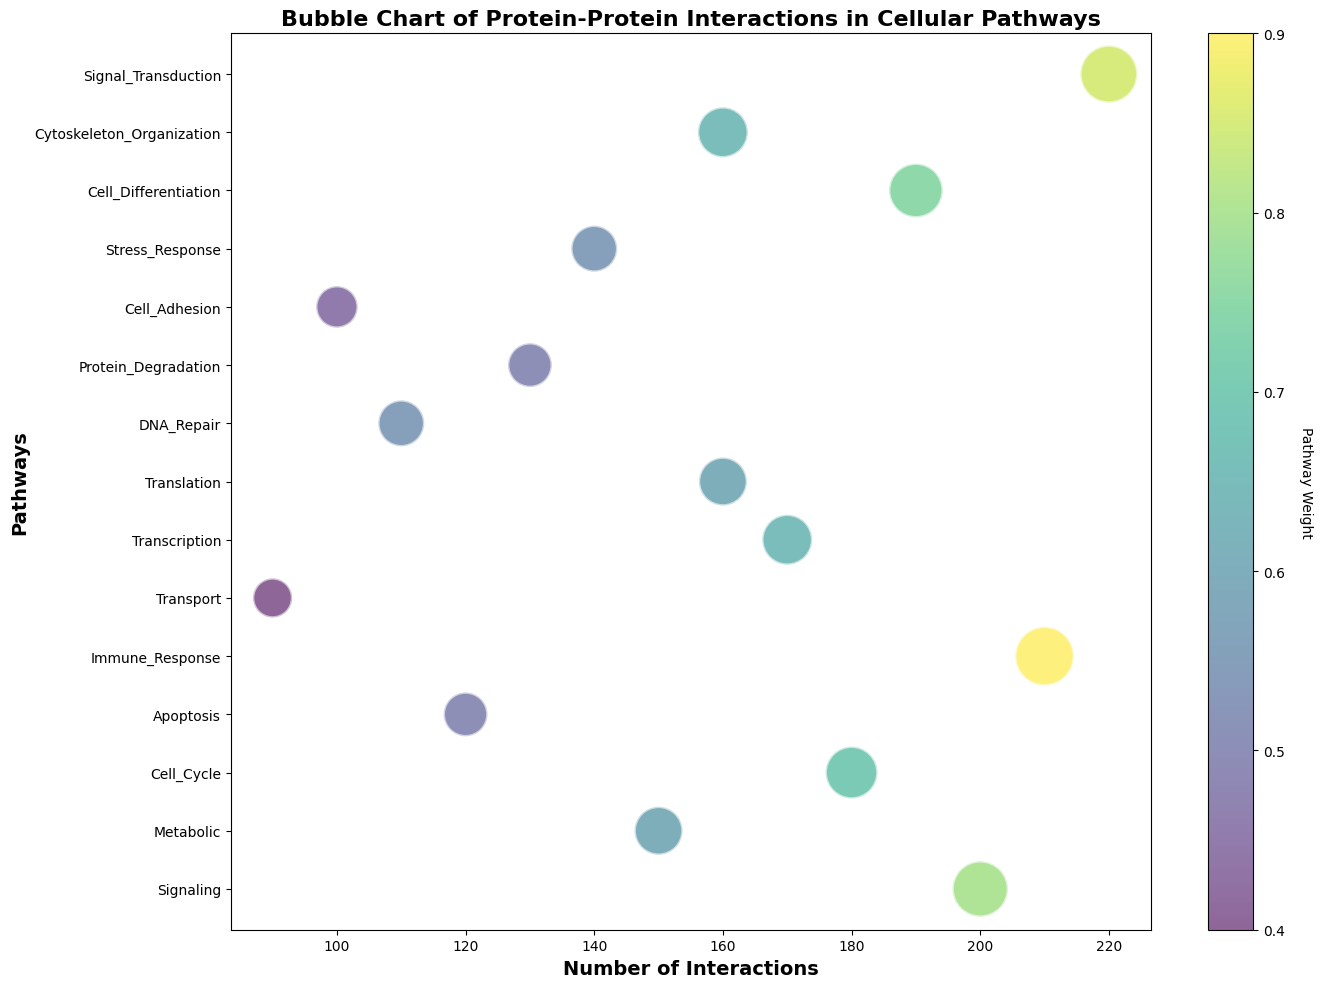Which pathway has the largest number of interactions? By examining the x-axis and identifying the path with the highest number, we find Signal_Transduction with 220 interactions.
Answer: Signal_Transduction Which pathway has the smallest number of interactions and what is that number? By observing the x-axis for the lowest number, we see that Transport has 90 interactions, the smallest number.
Answer: Transport, 90 Which pathway is assigned the highest weight and what is that weight? The color bar indicates the weight. Immune_Response has the deepest color, corresponding to a weight of 0.9.
Answer: Immune_Response, 0.9 Between Cell_Adhesion and Transport, which has more interactions and by how much? Cell_Adhesion has 100 interactions and Transport has 90 interactions. The difference is 100 - 90 = 10 interactions.
Answer: Cell_Adhesion, 10 interactions Does the pathway with the highest weight have the highest number of interactions? Immune_Response has the highest weight (0.9) but not the highest number of interactions. Signal_Transduction has more interactions (220).
Answer: No Which pathway has the smallest weight and what is that weight? The lightest color corresponds to the smallest weight. Transport has the smallest weight of 0.4.
Answer: Transport, 0.4 What is the average number of interactions across all pathways? Sum all interactions and divide by the number of pathways (15). Sum = 200 + 150 + 180 + 120 + 210 + 90 + 170 + 160 + 110 + 130 + 100 + 140 + 190 + 160 + 220 = 2240. Average = 2240/15 = 149.33 interactions.
Answer: 149.33 interactions Which pathway has the largest sized bubble and what does that represent? Bubble size is proportional to weight. Signal_Transduction and Immune_Response have the largest bubbles representing weights of 0.85 and 0.9.
Answer: Immune_Response, 0.9 Are there any pathways with equal number of interactions? If yes, name them. Observe repeating numbers on the x-axis. Both Translation and Cytoskeleton_Organization have 160 interactions.
Answer: Translation and Cytoskeleton_Organization What is the combined number of interactions for Signaling, Metabolic, and Cell_Cycle pathways? Add interactions for these pathways: 200 + 150 + 180 = 530 interactions.
Answer: 530 interactions 